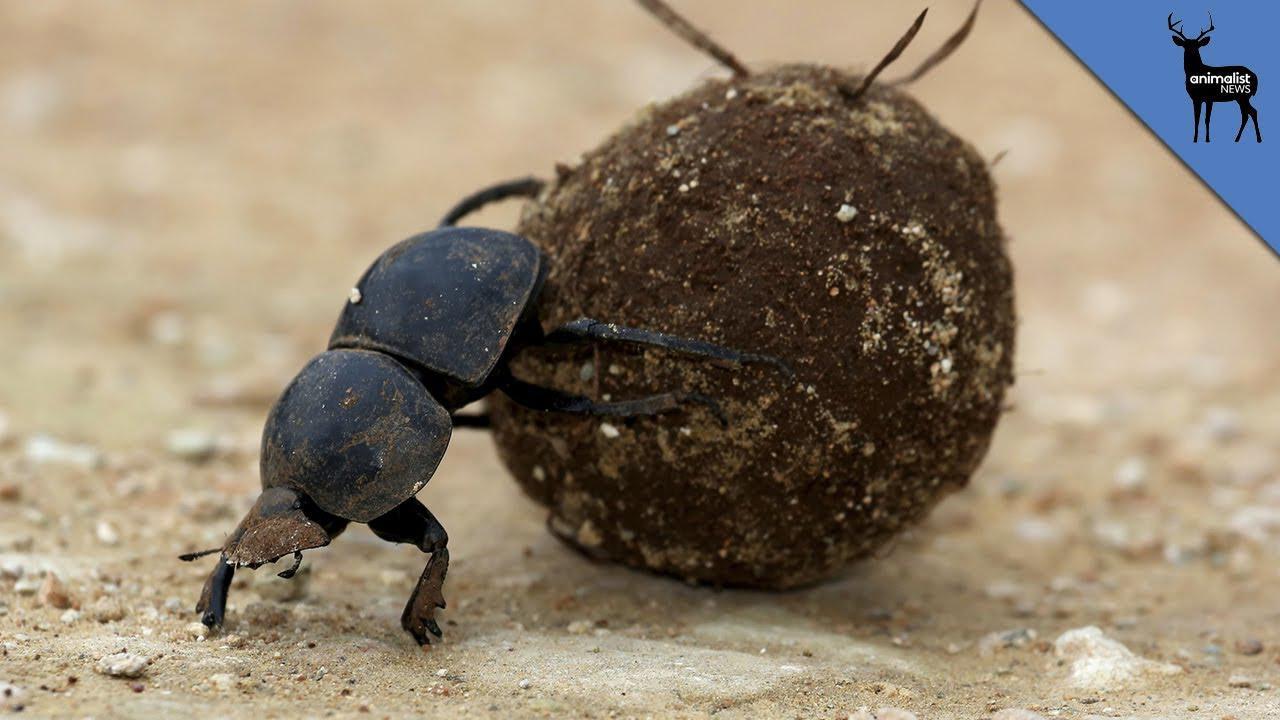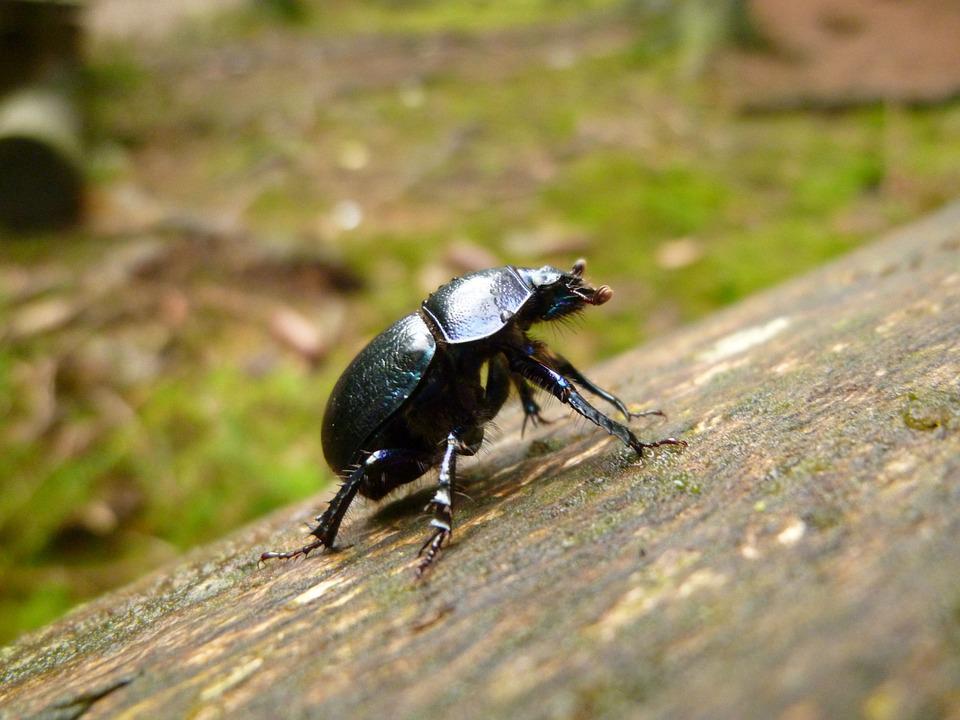The first image is the image on the left, the second image is the image on the right. Evaluate the accuracy of this statement regarding the images: "The beetle in the image on the left is on the right of the ball of dirt.". Is it true? Answer yes or no. No. The first image is the image on the left, the second image is the image on the right. Examine the images to the left and right. Is the description "An image shows a beetle with its hind legs on a dung ball and its head facing the ground." accurate? Answer yes or no. Yes. 